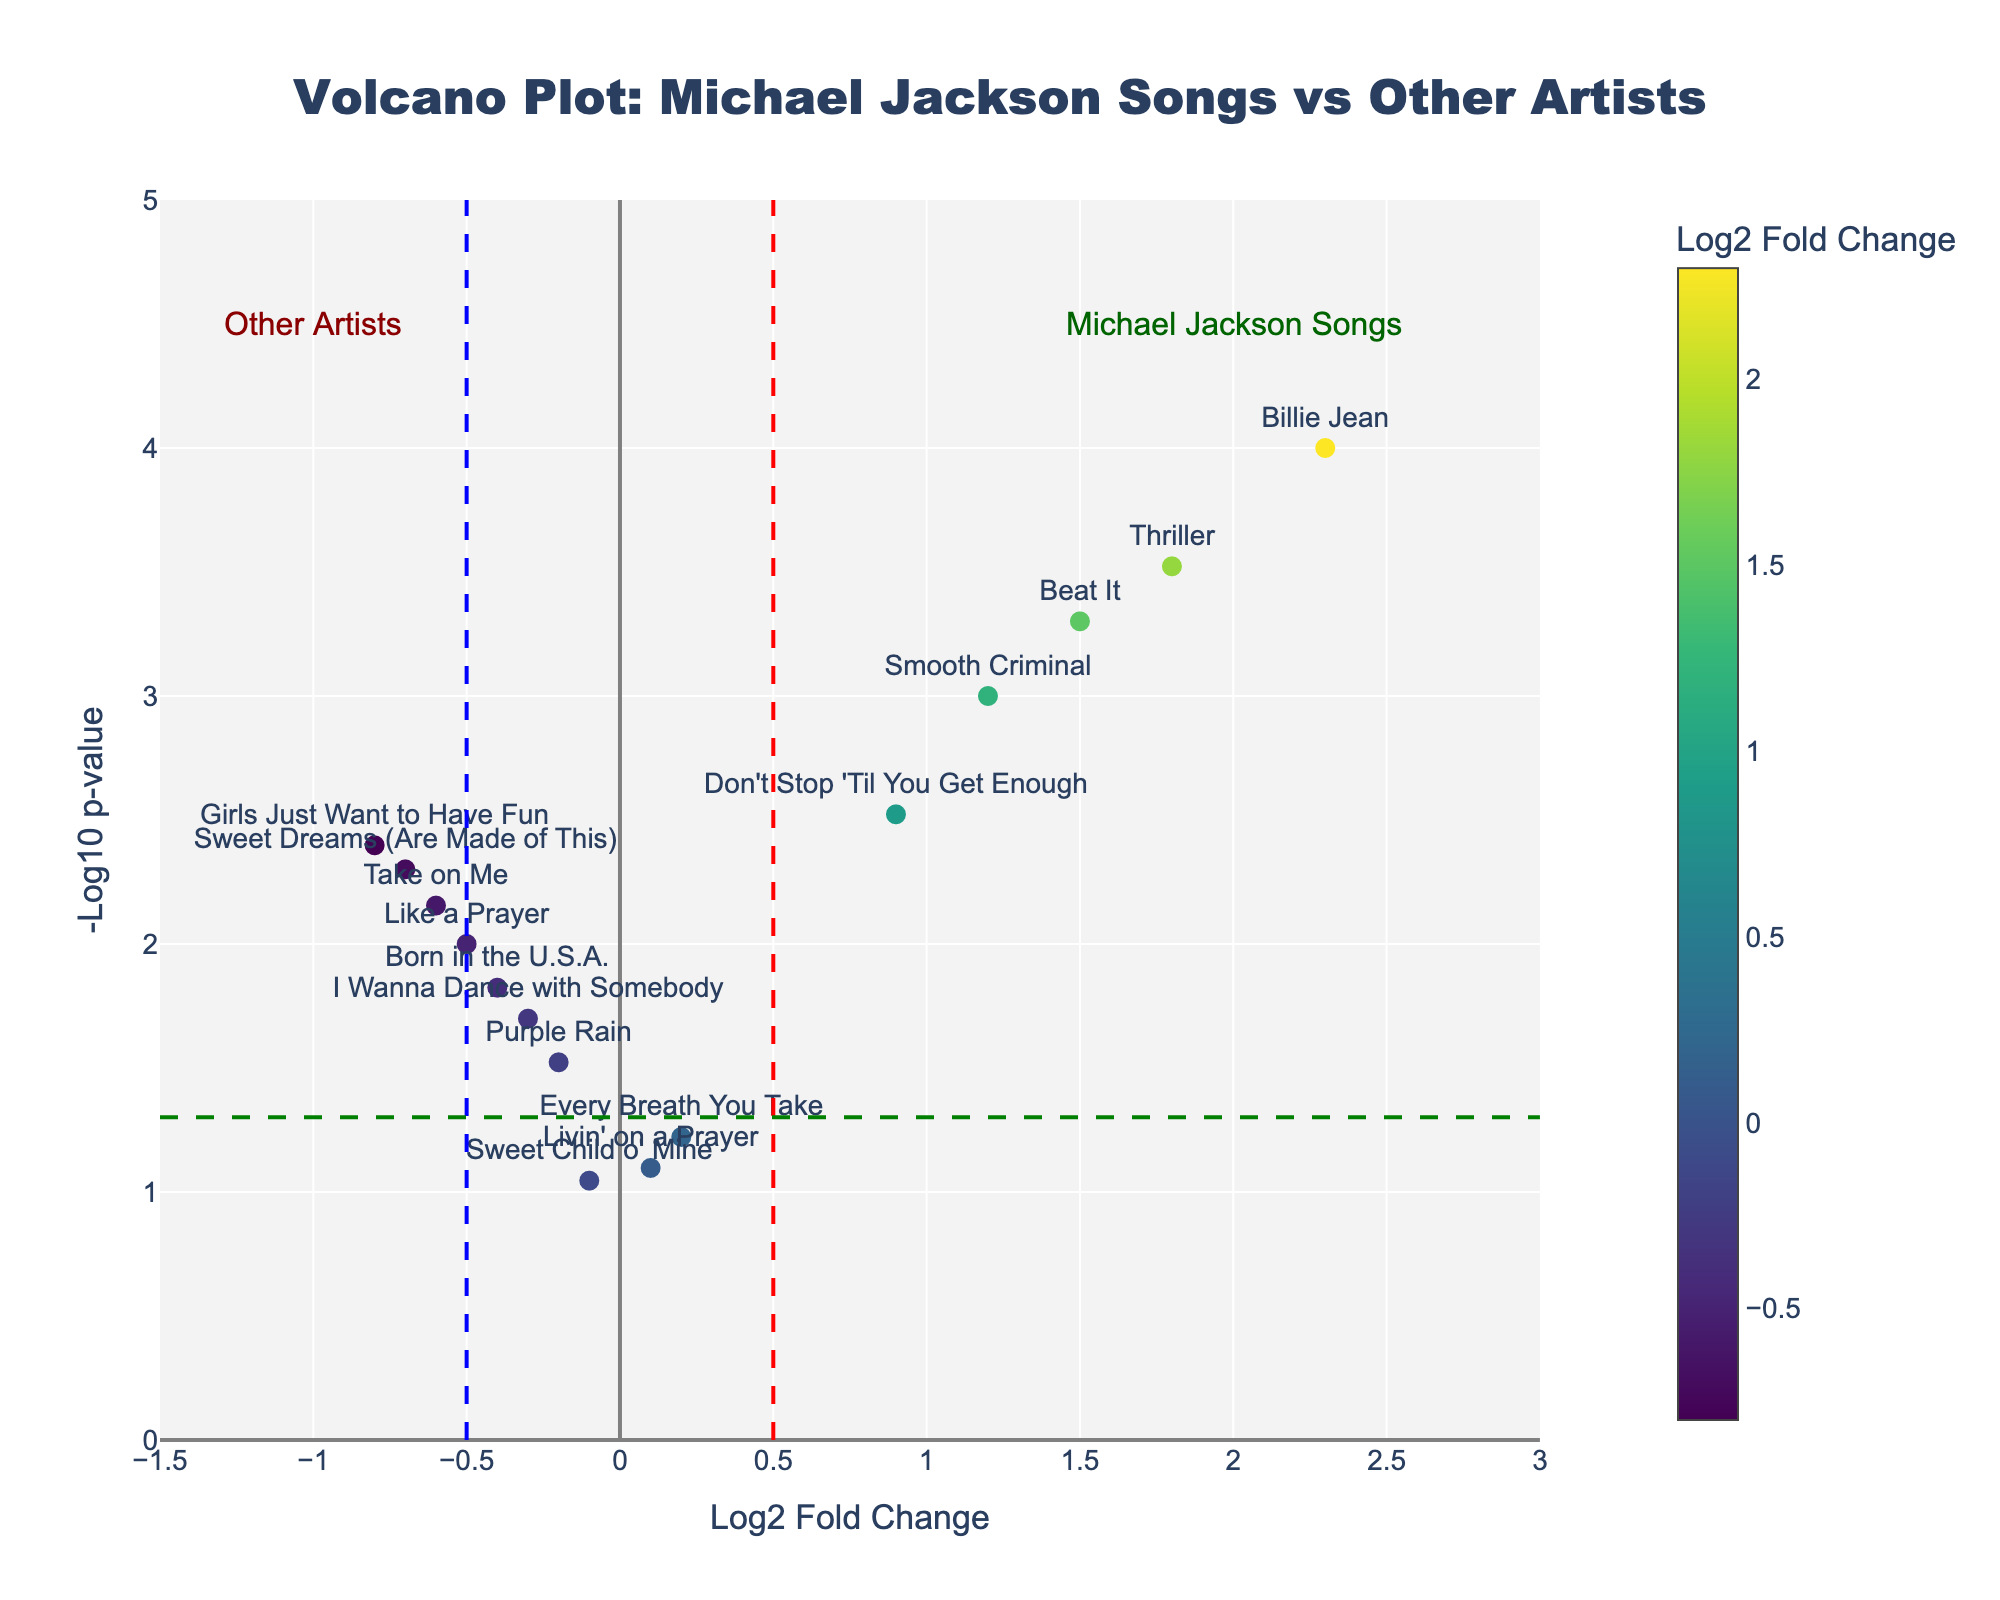How many songs are by Michael Jackson? Count the data points labeled with Michael Jackson song titles ("Billie Jean", "Thriller", "Beat It", "Smooth Criminal", "Don't Stop 'Til You Get Enough"). There are 5 of them.
Answer: 5 What is the log2 fold change for the song "Thriller"? Look at the x-axis value for the data point labeled "Thriller". It is 1.8.
Answer: 1.8 Which song has the highest audience engagement metric? Highest engagement is represented by the highest log2 fold change. "Billie Jean" has the log2 fold change of 2.3, the highest among all.
Answer: Billie Jean What is the p-value for "Like a Prayer"? Locate the data point for "Like a Prayer" and read its y-axis value converted from -log10(p-value). Its -log10(p-value) is 2, which converts back to a p-value of 0.01.
Answer: 0.01 Which Michael Jackson song is the closest to the p-value threshold line? The p-value threshold line is at -log10(0.05) which is 1.3. "Don't Stop 'Til You Get Enough" is the closest with a -log10(p-value) of about 2.5.
Answer: Don't Stop 'Til You Get Enough Between "I Wanna Dance with Somebody" and "Billie Jean", which song has a lower p-value? Compare the -log10(p-value): "I Wanna Dance with Somebody" has -log10(p-value) around 1.7, while "Billie Jean" has above 3. Therefore, "Billie Jean" has a lower p-value.
Answer: Billie Jean What is the significance level of the song "Beat It"? The significance level is -log10(p-value). For "Beat It", it appears around 3 from the y-axis.
Answer: 3 How many songs have a log2 fold change greater than 0.5? Count the data points with log2 fold change values greater than 0.5: "Billie Jean", "Thriller", "Beat It", and "Smooth Criminal". There are 4.
Answer: 4 Which song has the lowest engagement metric among Michael Jackson's songs? Compare the log2 fold change of all Michael Jackson's songs and find the smallest value. "Don't Stop 'Til You Get Enough" has the lowest with 0.9.
Answer: Don't Stop 'Til You Get Enough How many songs have a p-value less than 0.05? Count the number of data points above the horizontal green line representing -log10(0.05). There are 10 songs.
Answer: 10 